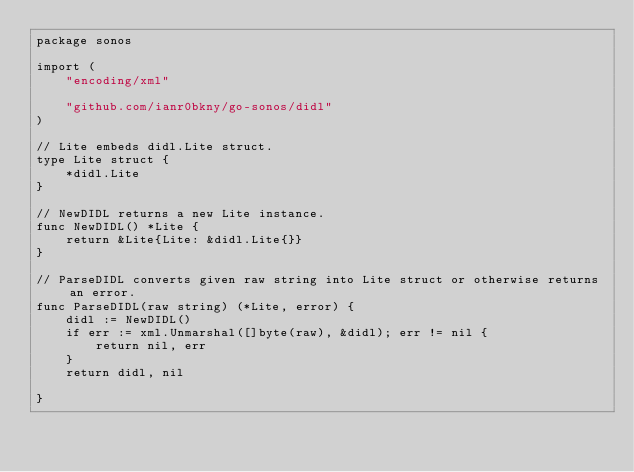<code> <loc_0><loc_0><loc_500><loc_500><_Go_>package sonos

import (
	"encoding/xml"

	"github.com/ianr0bkny/go-sonos/didl"
)

// Lite embeds didl.Lite struct.
type Lite struct {
	*didl.Lite
}

// NewDIDL returns a new Lite instance.
func NewDIDL() *Lite {
	return &Lite{Lite: &didl.Lite{}}
}

// ParseDIDL converts given raw string into Lite struct or otherwise returns an error.
func ParseDIDL(raw string) (*Lite, error) {
	didl := NewDIDL()
	if err := xml.Unmarshal([]byte(raw), &didl); err != nil {
		return nil, err
	}
	return didl, nil

}
</code> 